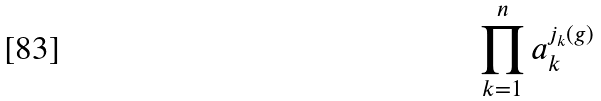<formula> <loc_0><loc_0><loc_500><loc_500>\prod _ { k = 1 } ^ { n } a _ { k } ^ { j _ { k } ( g ) }</formula> 